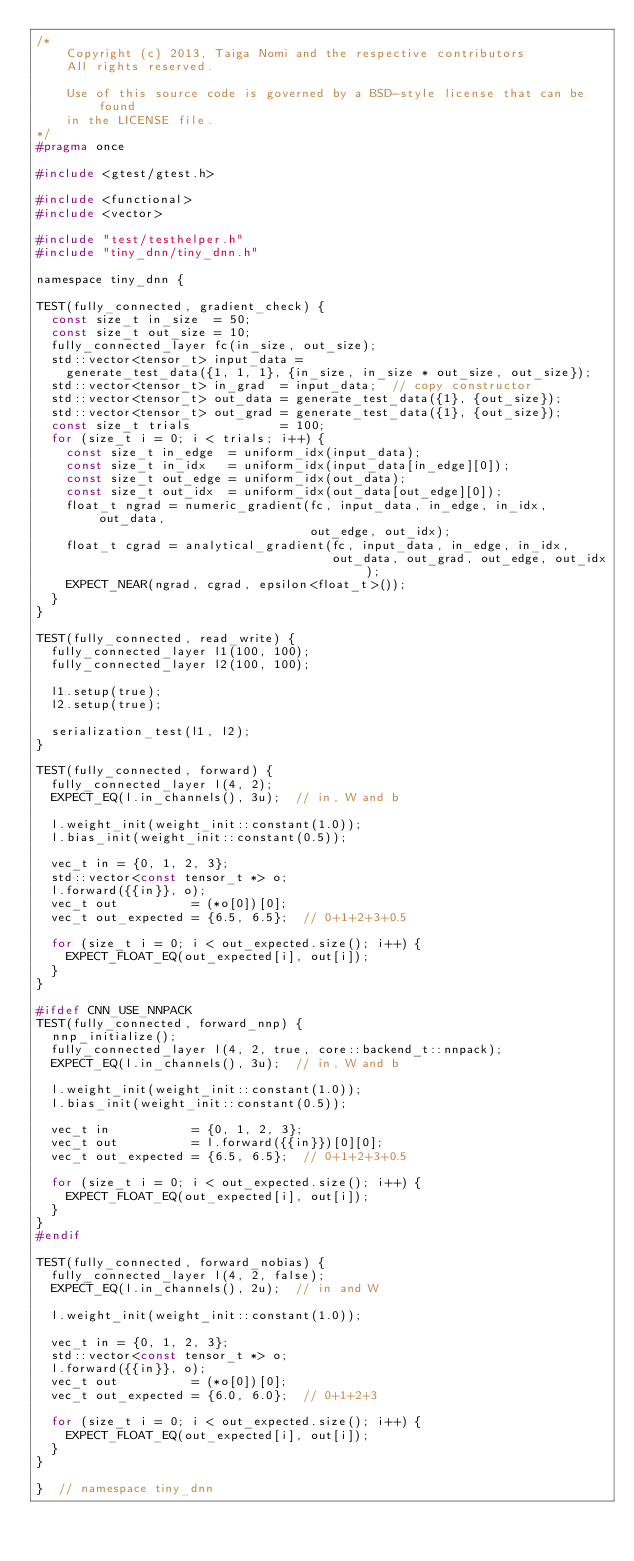<code> <loc_0><loc_0><loc_500><loc_500><_C_>/*
    Copyright (c) 2013, Taiga Nomi and the respective contributors
    All rights reserved.

    Use of this source code is governed by a BSD-style license that can be found
    in the LICENSE file.
*/
#pragma once

#include <gtest/gtest.h>

#include <functional>
#include <vector>

#include "test/testhelper.h"
#include "tiny_dnn/tiny_dnn.h"

namespace tiny_dnn {

TEST(fully_connected, gradient_check) {
  const size_t in_size  = 50;
  const size_t out_size = 10;
  fully_connected_layer fc(in_size, out_size);
  std::vector<tensor_t> input_data =
    generate_test_data({1, 1, 1}, {in_size, in_size * out_size, out_size});
  std::vector<tensor_t> in_grad  = input_data;  // copy constructor
  std::vector<tensor_t> out_data = generate_test_data({1}, {out_size});
  std::vector<tensor_t> out_grad = generate_test_data({1}, {out_size});
  const size_t trials            = 100;
  for (size_t i = 0; i < trials; i++) {
    const size_t in_edge  = uniform_idx(input_data);
    const size_t in_idx   = uniform_idx(input_data[in_edge][0]);
    const size_t out_edge = uniform_idx(out_data);
    const size_t out_idx  = uniform_idx(out_data[out_edge][0]);
    float_t ngrad = numeric_gradient(fc, input_data, in_edge, in_idx, out_data,
                                     out_edge, out_idx);
    float_t cgrad = analytical_gradient(fc, input_data, in_edge, in_idx,
                                        out_data, out_grad, out_edge, out_idx);
    EXPECT_NEAR(ngrad, cgrad, epsilon<float_t>());
  }
}

TEST(fully_connected, read_write) {
  fully_connected_layer l1(100, 100);
  fully_connected_layer l2(100, 100);

  l1.setup(true);
  l2.setup(true);

  serialization_test(l1, l2);
}

TEST(fully_connected, forward) {
  fully_connected_layer l(4, 2);
  EXPECT_EQ(l.in_channels(), 3u);  // in, W and b

  l.weight_init(weight_init::constant(1.0));
  l.bias_init(weight_init::constant(0.5));

  vec_t in = {0, 1, 2, 3};
  std::vector<const tensor_t *> o;
  l.forward({{in}}, o);
  vec_t out          = (*o[0])[0];
  vec_t out_expected = {6.5, 6.5};  // 0+1+2+3+0.5

  for (size_t i = 0; i < out_expected.size(); i++) {
    EXPECT_FLOAT_EQ(out_expected[i], out[i]);
  }
}

#ifdef CNN_USE_NNPACK
TEST(fully_connected, forward_nnp) {
  nnp_initialize();
  fully_connected_layer l(4, 2, true, core::backend_t::nnpack);
  EXPECT_EQ(l.in_channels(), 3u);  // in, W and b

  l.weight_init(weight_init::constant(1.0));
  l.bias_init(weight_init::constant(0.5));

  vec_t in           = {0, 1, 2, 3};
  vec_t out          = l.forward({{in}})[0][0];
  vec_t out_expected = {6.5, 6.5};  // 0+1+2+3+0.5

  for (size_t i = 0; i < out_expected.size(); i++) {
    EXPECT_FLOAT_EQ(out_expected[i], out[i]);
  }
}
#endif

TEST(fully_connected, forward_nobias) {
  fully_connected_layer l(4, 2, false);
  EXPECT_EQ(l.in_channels(), 2u);  // in and W

  l.weight_init(weight_init::constant(1.0));

  vec_t in = {0, 1, 2, 3};
  std::vector<const tensor_t *> o;
  l.forward({{in}}, o);
  vec_t out          = (*o[0])[0];
  vec_t out_expected = {6.0, 6.0};  // 0+1+2+3

  for (size_t i = 0; i < out_expected.size(); i++) {
    EXPECT_FLOAT_EQ(out_expected[i], out[i]);
  }
}

}  // namespace tiny_dnn
</code> 